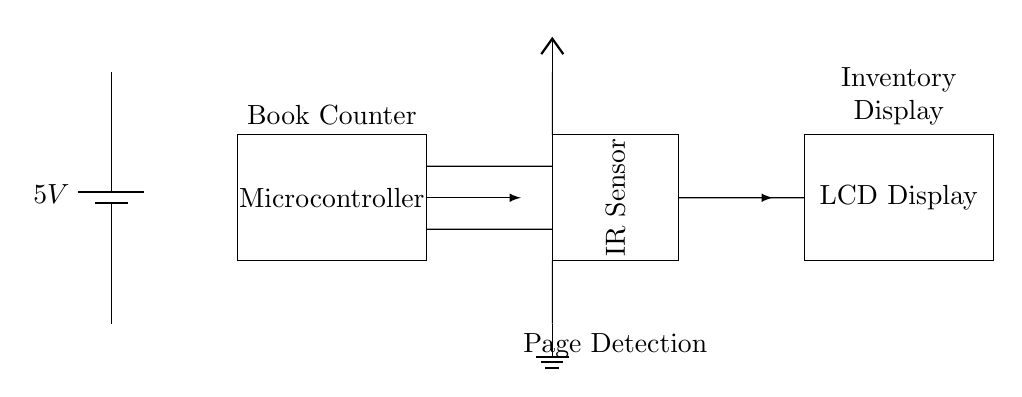What is the voltage of this circuit? The voltage of the circuit is indicated by the battery symbol, which displays a value of 5 volts. This is the power supply voltage that is required for the operation of the components in the circuit.
Answer: 5 volts What type of sensor is used in this circuit? The circuit diagram includes an IR sensor, as labeled in the rectangle. This type of sensor is used for detecting the presence of an object, in this case, the pages of a book.
Answer: IR sensor How many components are connected in series with the microcontroller? The microcontroller has two components connected in series: the IR sensor and the LCD display. Both are connected directively to the microcontroller without any intervening components.
Answer: Two What is the function of the LCD display in this circuit? The LCD display provides a visual output of the inventory. It is where the counts of pages detected by the IR sensor are shown, allowing the bookstore owner to track inventory easily.
Answer: Inventory display Which component detects page presence for counting? The IR sensor detects the pages by sensing interruptions in the infrared light beam as pages pass through it, allowing it to increment the count accordingly.
Answer: IR sensor What direction is the data flow from the microcontroller to the LCD display? The data flows from the microcontroller to the LCD display as indicated by the arrow, suggesting that the microcontroller sends the counted data to be displayed on the LCD. This signifies a one-way data transmission for output purposes.
Answer: Rightward 